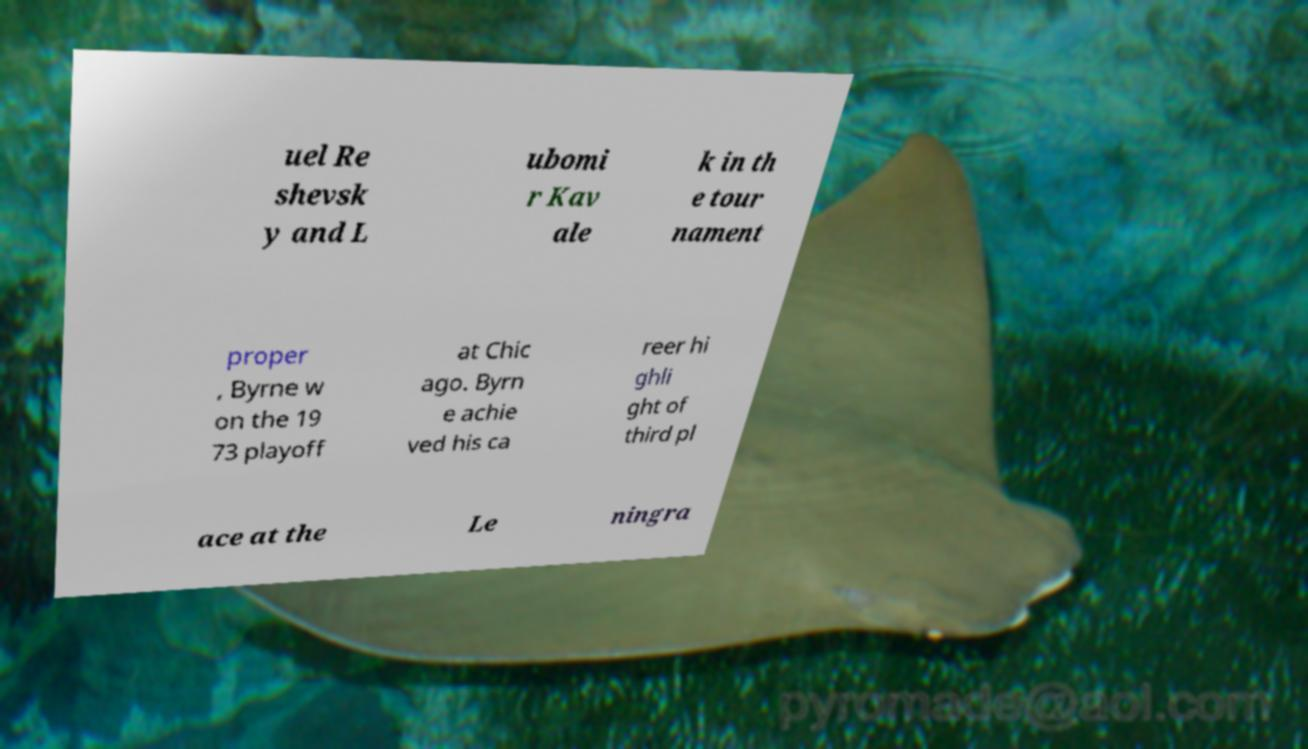Please read and relay the text visible in this image. What does it say? uel Re shevsk y and L ubomi r Kav ale k in th e tour nament proper , Byrne w on the 19 73 playoff at Chic ago. Byrn e achie ved his ca reer hi ghli ght of third pl ace at the Le ningra 